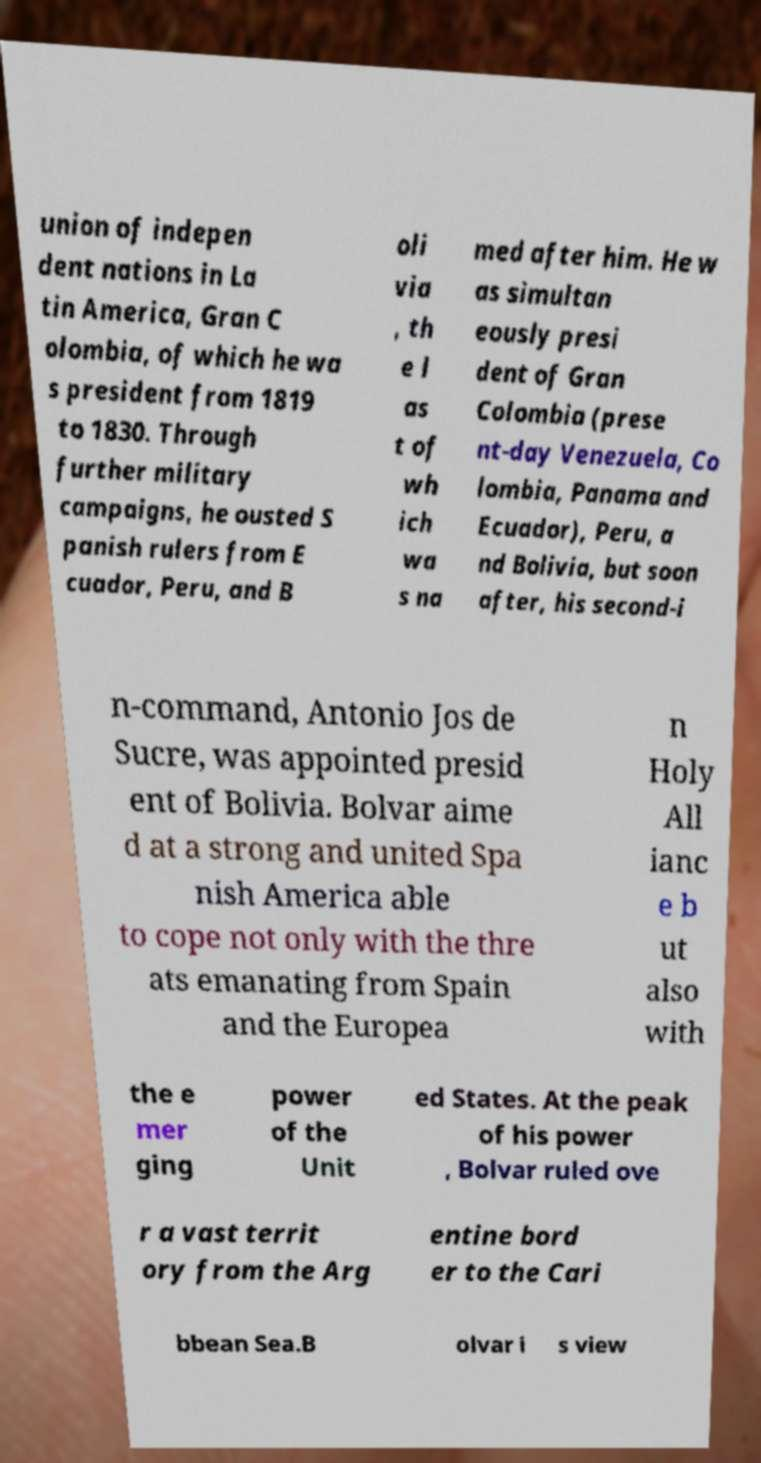What messages or text are displayed in this image? I need them in a readable, typed format. union of indepen dent nations in La tin America, Gran C olombia, of which he wa s president from 1819 to 1830. Through further military campaigns, he ousted S panish rulers from E cuador, Peru, and B oli via , th e l as t of wh ich wa s na med after him. He w as simultan eously presi dent of Gran Colombia (prese nt-day Venezuela, Co lombia, Panama and Ecuador), Peru, a nd Bolivia, but soon after, his second-i n-command, Antonio Jos de Sucre, was appointed presid ent of Bolivia. Bolvar aime d at a strong and united Spa nish America able to cope not only with the thre ats emanating from Spain and the Europea n Holy All ianc e b ut also with the e mer ging power of the Unit ed States. At the peak of his power , Bolvar ruled ove r a vast territ ory from the Arg entine bord er to the Cari bbean Sea.B olvar i s view 